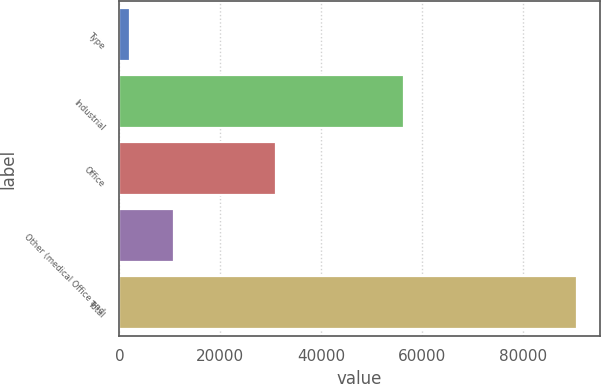Convert chart. <chart><loc_0><loc_0><loc_500><loc_500><bar_chart><fcel>Type<fcel>Industrial<fcel>Office<fcel>Other (medical Office and<fcel>Total<nl><fcel>2009<fcel>56426<fcel>31054<fcel>10866.2<fcel>90581<nl></chart> 